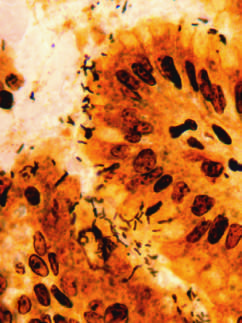s the atrium highlighted in this warthin-starry silver stain?
Answer the question using a single word or phrase. No 